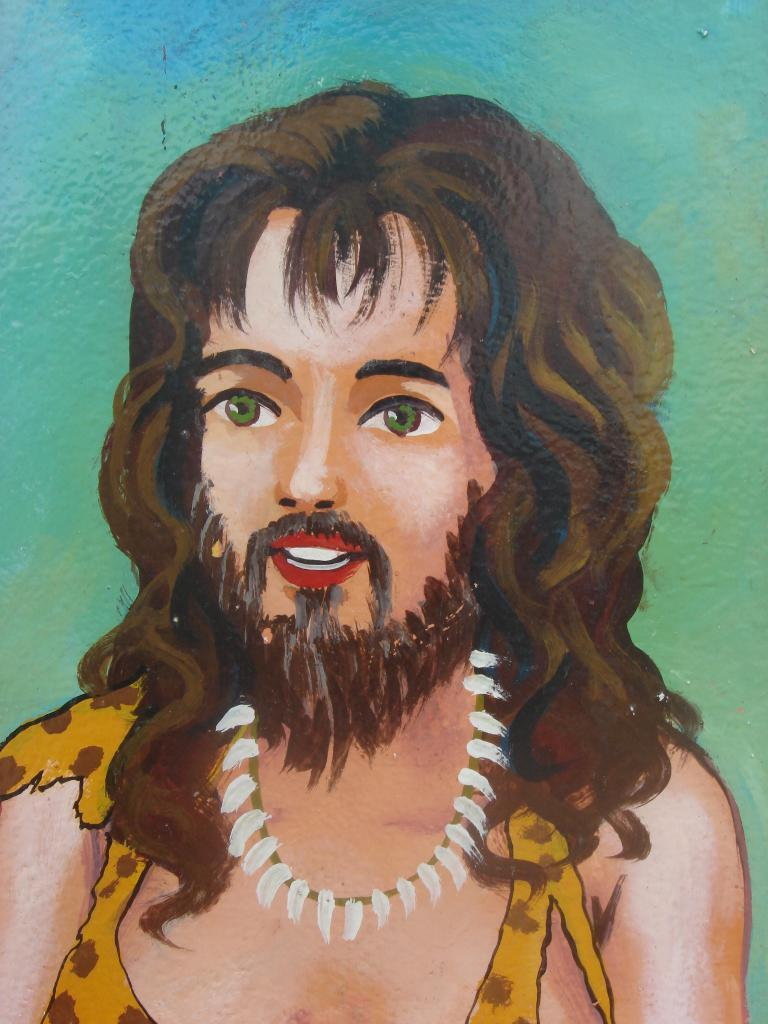What is the main subject of the image? The main subject of the image is a person's painting. Can you describe the background of the painting? The background of the painting is multicolored. How can you tell that the image is a painting? The image appears to be a painting, as it has a distinct style and brushstrokes. What type of badge is the person wearing in the painting? There is no person wearing a badge in the painting, as the image is a painting of the artwork itself and not a photograph of a person. What time of day is depicted in the painting? The time of day is not depicted in the painting, as it is an abstract representation of a person's artwork and does not include any specific time or setting. 